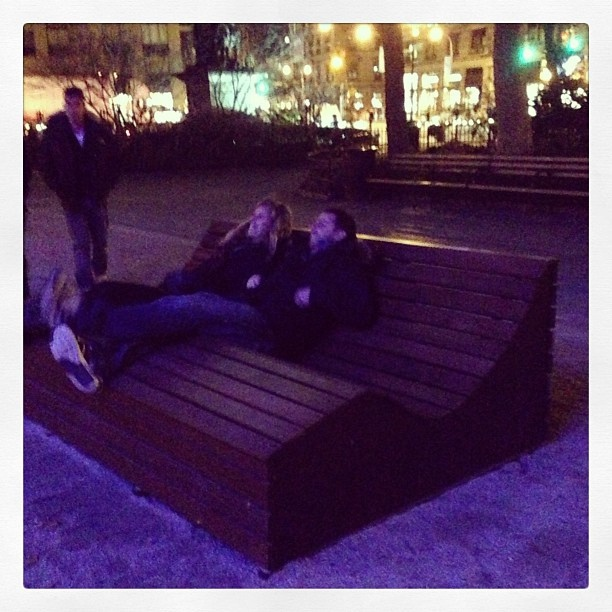Describe the objects in this image and their specific colors. I can see bench in whitesmoke, navy, purple, and darkblue tones, people in whitesmoke, navy, and purple tones, people in white, navy, and purple tones, people in whitesmoke, black, navy, and purple tones, and bench in whitesmoke, black, purple, and brown tones in this image. 